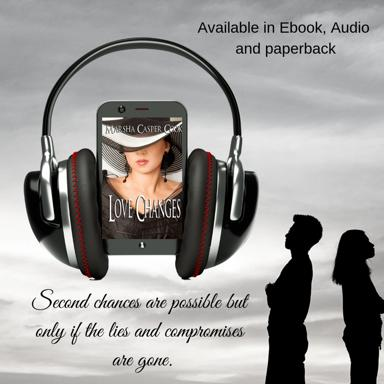What are the available formats of the content mentioned in the image? As showcased in the image, the novel 'Love Changes' by Sha Casper is versatile in its availability, offering readers the choice of an Ebook for digital convenience, an Audiobook for auditory pleasure, and a traditional paperback for those who appreciate the tactile sensation of turning pages. 